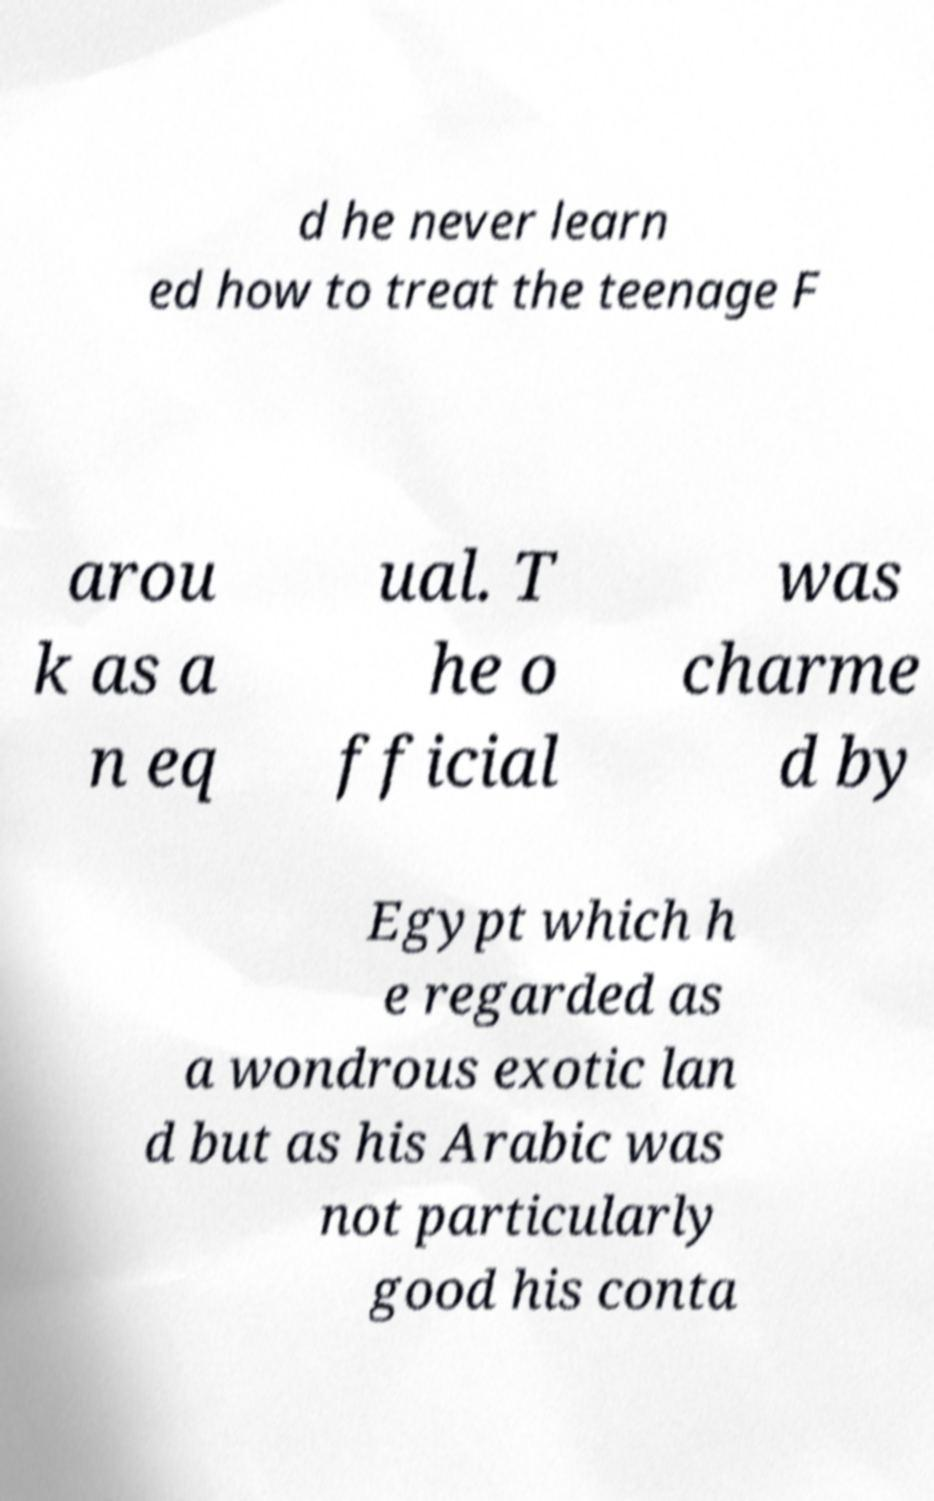Please identify and transcribe the text found in this image. d he never learn ed how to treat the teenage F arou k as a n eq ual. T he o fficial was charme d by Egypt which h e regarded as a wondrous exotic lan d but as his Arabic was not particularly good his conta 